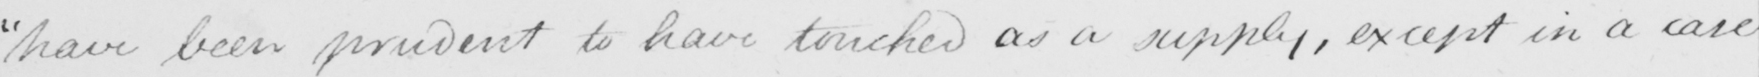What does this handwritten line say? have been prudent to have touched as a supply , except in a case 